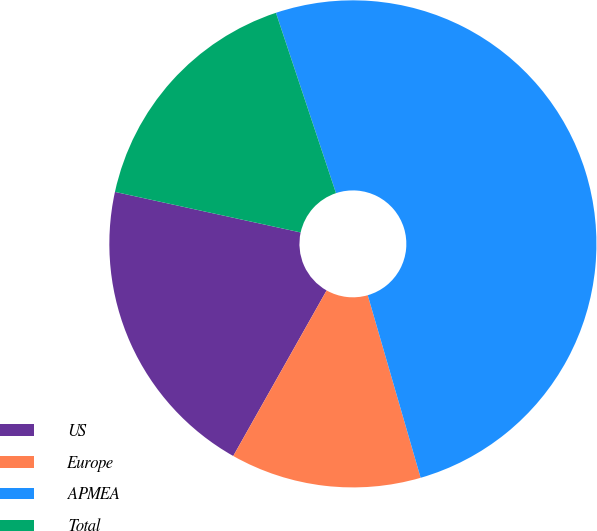Convert chart. <chart><loc_0><loc_0><loc_500><loc_500><pie_chart><fcel>US<fcel>Europe<fcel>APMEA<fcel>Total<nl><fcel>20.25%<fcel>12.66%<fcel>50.63%<fcel>16.46%<nl></chart> 